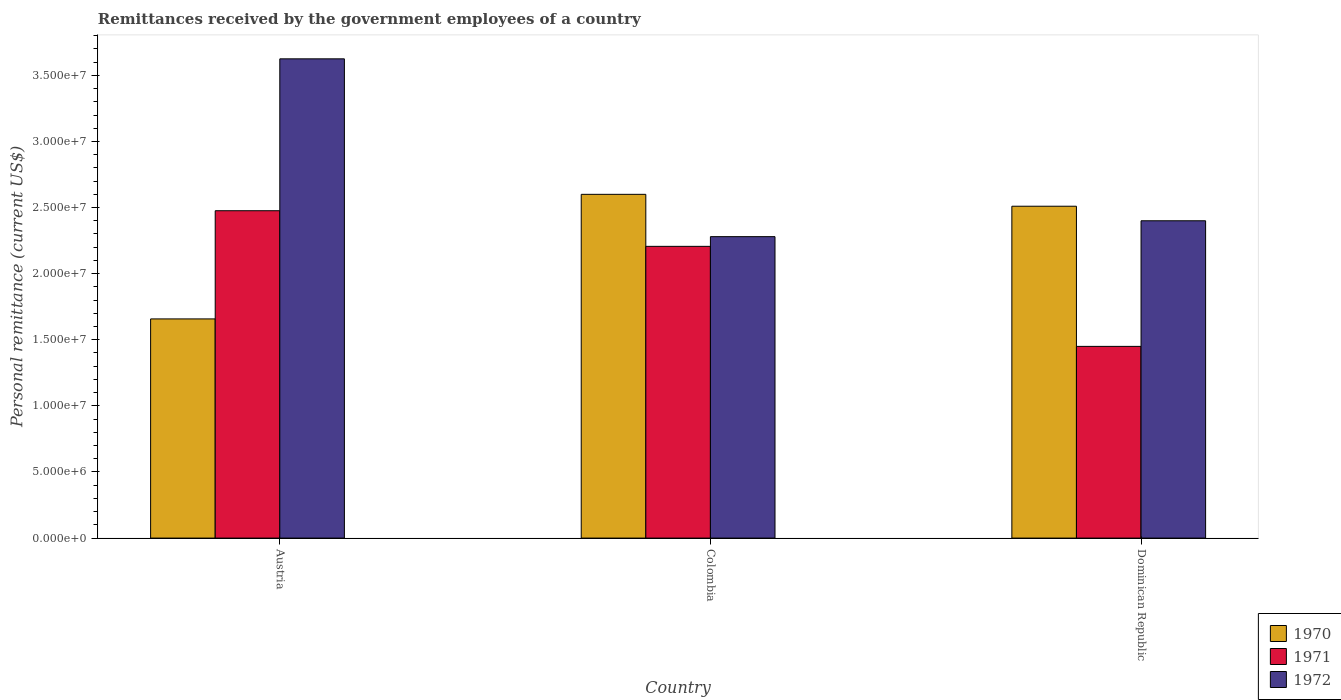How many different coloured bars are there?
Offer a very short reply. 3. How many bars are there on the 1st tick from the right?
Keep it short and to the point. 3. What is the label of the 2nd group of bars from the left?
Your answer should be very brief. Colombia. What is the remittances received by the government employees in 1971 in Colombia?
Make the answer very short. 2.21e+07. Across all countries, what is the maximum remittances received by the government employees in 1972?
Make the answer very short. 3.62e+07. Across all countries, what is the minimum remittances received by the government employees in 1970?
Offer a terse response. 1.66e+07. In which country was the remittances received by the government employees in 1971 maximum?
Your response must be concise. Austria. In which country was the remittances received by the government employees in 1971 minimum?
Offer a very short reply. Dominican Republic. What is the total remittances received by the government employees in 1972 in the graph?
Your answer should be compact. 8.30e+07. What is the difference between the remittances received by the government employees in 1971 in Colombia and that in Dominican Republic?
Provide a succinct answer. 7.57e+06. What is the average remittances received by the government employees in 1971 per country?
Offer a very short reply. 2.04e+07. What is the difference between the remittances received by the government employees of/in 1971 and remittances received by the government employees of/in 1970 in Dominican Republic?
Ensure brevity in your answer.  -1.06e+07. In how many countries, is the remittances received by the government employees in 1970 greater than 14000000 US$?
Offer a terse response. 3. What is the ratio of the remittances received by the government employees in 1971 in Colombia to that in Dominican Republic?
Offer a terse response. 1.52. Is the remittances received by the government employees in 1972 in Austria less than that in Colombia?
Your response must be concise. No. Is the difference between the remittances received by the government employees in 1971 in Austria and Colombia greater than the difference between the remittances received by the government employees in 1970 in Austria and Colombia?
Offer a very short reply. Yes. What is the difference between the highest and the second highest remittances received by the government employees in 1971?
Give a very brief answer. -1.03e+07. What is the difference between the highest and the lowest remittances received by the government employees in 1971?
Offer a very short reply. 1.03e+07. In how many countries, is the remittances received by the government employees in 1971 greater than the average remittances received by the government employees in 1971 taken over all countries?
Offer a terse response. 2. Is the sum of the remittances received by the government employees in 1972 in Austria and Colombia greater than the maximum remittances received by the government employees in 1970 across all countries?
Provide a short and direct response. Yes. What does the 3rd bar from the left in Dominican Republic represents?
Offer a very short reply. 1972. Is it the case that in every country, the sum of the remittances received by the government employees in 1970 and remittances received by the government employees in 1972 is greater than the remittances received by the government employees in 1971?
Provide a succinct answer. Yes. How many countries are there in the graph?
Give a very brief answer. 3. Are the values on the major ticks of Y-axis written in scientific E-notation?
Your answer should be compact. Yes. Does the graph contain any zero values?
Your answer should be very brief. No. Does the graph contain grids?
Ensure brevity in your answer.  No. Where does the legend appear in the graph?
Offer a terse response. Bottom right. How many legend labels are there?
Your answer should be very brief. 3. What is the title of the graph?
Your response must be concise. Remittances received by the government employees of a country. What is the label or title of the X-axis?
Make the answer very short. Country. What is the label or title of the Y-axis?
Make the answer very short. Personal remittance (current US$). What is the Personal remittance (current US$) in 1970 in Austria?
Offer a very short reply. 1.66e+07. What is the Personal remittance (current US$) in 1971 in Austria?
Offer a very short reply. 2.48e+07. What is the Personal remittance (current US$) of 1972 in Austria?
Make the answer very short. 3.62e+07. What is the Personal remittance (current US$) of 1970 in Colombia?
Your response must be concise. 2.60e+07. What is the Personal remittance (current US$) of 1971 in Colombia?
Keep it short and to the point. 2.21e+07. What is the Personal remittance (current US$) of 1972 in Colombia?
Make the answer very short. 2.28e+07. What is the Personal remittance (current US$) in 1970 in Dominican Republic?
Ensure brevity in your answer.  2.51e+07. What is the Personal remittance (current US$) of 1971 in Dominican Republic?
Give a very brief answer. 1.45e+07. What is the Personal remittance (current US$) of 1972 in Dominican Republic?
Keep it short and to the point. 2.40e+07. Across all countries, what is the maximum Personal remittance (current US$) of 1970?
Provide a succinct answer. 2.60e+07. Across all countries, what is the maximum Personal remittance (current US$) in 1971?
Your answer should be very brief. 2.48e+07. Across all countries, what is the maximum Personal remittance (current US$) in 1972?
Ensure brevity in your answer.  3.62e+07. Across all countries, what is the minimum Personal remittance (current US$) in 1970?
Offer a very short reply. 1.66e+07. Across all countries, what is the minimum Personal remittance (current US$) in 1971?
Your answer should be very brief. 1.45e+07. Across all countries, what is the minimum Personal remittance (current US$) in 1972?
Provide a succinct answer. 2.28e+07. What is the total Personal remittance (current US$) in 1970 in the graph?
Ensure brevity in your answer.  6.77e+07. What is the total Personal remittance (current US$) in 1971 in the graph?
Keep it short and to the point. 6.13e+07. What is the total Personal remittance (current US$) of 1972 in the graph?
Make the answer very short. 8.30e+07. What is the difference between the Personal remittance (current US$) of 1970 in Austria and that in Colombia?
Your answer should be compact. -9.42e+06. What is the difference between the Personal remittance (current US$) in 1971 in Austria and that in Colombia?
Provide a short and direct response. 2.69e+06. What is the difference between the Personal remittance (current US$) in 1972 in Austria and that in Colombia?
Ensure brevity in your answer.  1.34e+07. What is the difference between the Personal remittance (current US$) in 1970 in Austria and that in Dominican Republic?
Provide a short and direct response. -8.52e+06. What is the difference between the Personal remittance (current US$) in 1971 in Austria and that in Dominican Republic?
Make the answer very short. 1.03e+07. What is the difference between the Personal remittance (current US$) in 1972 in Austria and that in Dominican Republic?
Keep it short and to the point. 1.22e+07. What is the difference between the Personal remittance (current US$) of 1970 in Colombia and that in Dominican Republic?
Your answer should be very brief. 9.00e+05. What is the difference between the Personal remittance (current US$) of 1971 in Colombia and that in Dominican Republic?
Your answer should be compact. 7.57e+06. What is the difference between the Personal remittance (current US$) of 1972 in Colombia and that in Dominican Republic?
Ensure brevity in your answer.  -1.20e+06. What is the difference between the Personal remittance (current US$) of 1970 in Austria and the Personal remittance (current US$) of 1971 in Colombia?
Make the answer very short. -5.49e+06. What is the difference between the Personal remittance (current US$) of 1970 in Austria and the Personal remittance (current US$) of 1972 in Colombia?
Keep it short and to the point. -6.22e+06. What is the difference between the Personal remittance (current US$) in 1971 in Austria and the Personal remittance (current US$) in 1972 in Colombia?
Offer a very short reply. 1.96e+06. What is the difference between the Personal remittance (current US$) in 1970 in Austria and the Personal remittance (current US$) in 1971 in Dominican Republic?
Your answer should be compact. 2.08e+06. What is the difference between the Personal remittance (current US$) in 1970 in Austria and the Personal remittance (current US$) in 1972 in Dominican Republic?
Offer a very short reply. -7.42e+06. What is the difference between the Personal remittance (current US$) in 1971 in Austria and the Personal remittance (current US$) in 1972 in Dominican Republic?
Your answer should be compact. 7.60e+05. What is the difference between the Personal remittance (current US$) of 1970 in Colombia and the Personal remittance (current US$) of 1971 in Dominican Republic?
Provide a short and direct response. 1.15e+07. What is the difference between the Personal remittance (current US$) in 1971 in Colombia and the Personal remittance (current US$) in 1972 in Dominican Republic?
Your answer should be very brief. -1.93e+06. What is the average Personal remittance (current US$) in 1970 per country?
Offer a terse response. 2.26e+07. What is the average Personal remittance (current US$) of 1971 per country?
Keep it short and to the point. 2.04e+07. What is the average Personal remittance (current US$) of 1972 per country?
Offer a terse response. 2.77e+07. What is the difference between the Personal remittance (current US$) in 1970 and Personal remittance (current US$) in 1971 in Austria?
Provide a short and direct response. -8.18e+06. What is the difference between the Personal remittance (current US$) in 1970 and Personal remittance (current US$) in 1972 in Austria?
Make the answer very short. -1.97e+07. What is the difference between the Personal remittance (current US$) of 1971 and Personal remittance (current US$) of 1972 in Austria?
Provide a short and direct response. -1.15e+07. What is the difference between the Personal remittance (current US$) in 1970 and Personal remittance (current US$) in 1971 in Colombia?
Provide a short and direct response. 3.93e+06. What is the difference between the Personal remittance (current US$) of 1970 and Personal remittance (current US$) of 1972 in Colombia?
Offer a very short reply. 3.20e+06. What is the difference between the Personal remittance (current US$) in 1971 and Personal remittance (current US$) in 1972 in Colombia?
Offer a terse response. -7.34e+05. What is the difference between the Personal remittance (current US$) in 1970 and Personal remittance (current US$) in 1971 in Dominican Republic?
Make the answer very short. 1.06e+07. What is the difference between the Personal remittance (current US$) of 1970 and Personal remittance (current US$) of 1972 in Dominican Republic?
Provide a succinct answer. 1.10e+06. What is the difference between the Personal remittance (current US$) in 1971 and Personal remittance (current US$) in 1972 in Dominican Republic?
Give a very brief answer. -9.50e+06. What is the ratio of the Personal remittance (current US$) of 1970 in Austria to that in Colombia?
Provide a succinct answer. 0.64. What is the ratio of the Personal remittance (current US$) of 1971 in Austria to that in Colombia?
Provide a succinct answer. 1.12. What is the ratio of the Personal remittance (current US$) in 1972 in Austria to that in Colombia?
Make the answer very short. 1.59. What is the ratio of the Personal remittance (current US$) in 1970 in Austria to that in Dominican Republic?
Provide a short and direct response. 0.66. What is the ratio of the Personal remittance (current US$) of 1971 in Austria to that in Dominican Republic?
Make the answer very short. 1.71. What is the ratio of the Personal remittance (current US$) of 1972 in Austria to that in Dominican Republic?
Your answer should be compact. 1.51. What is the ratio of the Personal remittance (current US$) of 1970 in Colombia to that in Dominican Republic?
Your response must be concise. 1.04. What is the ratio of the Personal remittance (current US$) in 1971 in Colombia to that in Dominican Republic?
Your response must be concise. 1.52. What is the ratio of the Personal remittance (current US$) in 1972 in Colombia to that in Dominican Republic?
Your answer should be compact. 0.95. What is the difference between the highest and the second highest Personal remittance (current US$) of 1970?
Offer a very short reply. 9.00e+05. What is the difference between the highest and the second highest Personal remittance (current US$) in 1971?
Offer a terse response. 2.69e+06. What is the difference between the highest and the second highest Personal remittance (current US$) of 1972?
Your answer should be compact. 1.22e+07. What is the difference between the highest and the lowest Personal remittance (current US$) of 1970?
Ensure brevity in your answer.  9.42e+06. What is the difference between the highest and the lowest Personal remittance (current US$) of 1971?
Provide a succinct answer. 1.03e+07. What is the difference between the highest and the lowest Personal remittance (current US$) of 1972?
Provide a short and direct response. 1.34e+07. 